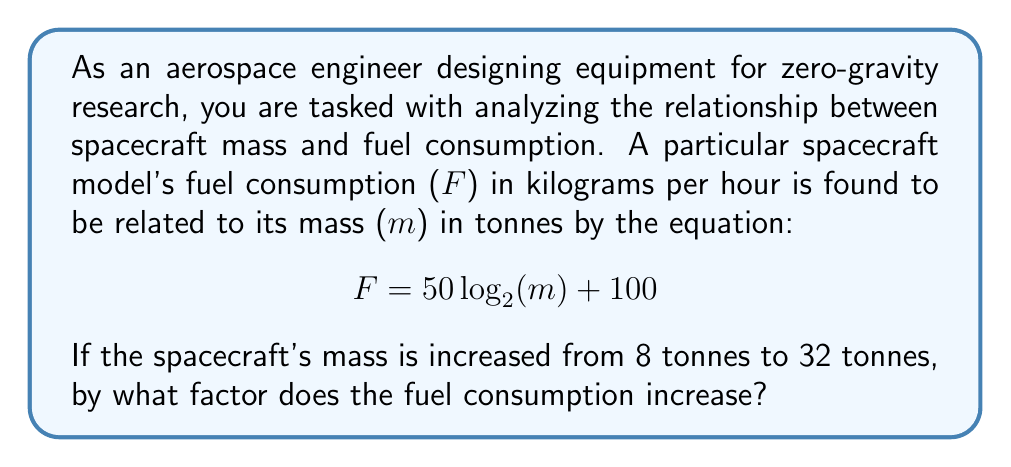What is the answer to this math problem? To solve this problem, we need to calculate the fuel consumption for both masses and then find the ratio between them. Let's break it down step-by-step:

1) First, let's calculate the fuel consumption for m = 8 tonnes:
   $$ F_1 = 50 \log_2(8) + 100 $$
   $$ F_1 = 50 \cdot 3 + 100 = 250 \text{ kg/hour} $$

2) Now, let's calculate the fuel consumption for m = 32 tonnes:
   $$ F_2 = 50 \log_2(32) + 100 $$
   $$ F_2 = 50 \cdot 5 + 100 = 350 \text{ kg/hour} $$

3) To find the factor by which fuel consumption increases, we divide F_2 by F_1:
   $$ \text{Factor} = \frac{F_2}{F_1} = \frac{350}{250} = 1.4 $$

4) We can verify this using the properties of logarithms:
   $$ \frac{F_2 - 100}{F_1 - 100} = \frac{\log_2(32)}{\log_2(8)} = \frac{5}{3} = \frac{250}{150} = \frac{5}{3} $$

   This ratio is consistent with our calculated factor of 1.4.

5) The relationship between mass and fuel consumption is logarithmic, which means that a linear increase in mass results in a smaller, non-linear increase in fuel consumption. This is why quadrupling the mass (from 8 to 32 tonnes) only results in a 1.4-fold increase in fuel consumption.
Answer: The fuel consumption increases by a factor of 1.4 when the spacecraft's mass is increased from 8 tonnes to 32 tonnes. 